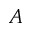<formula> <loc_0><loc_0><loc_500><loc_500>A</formula> 